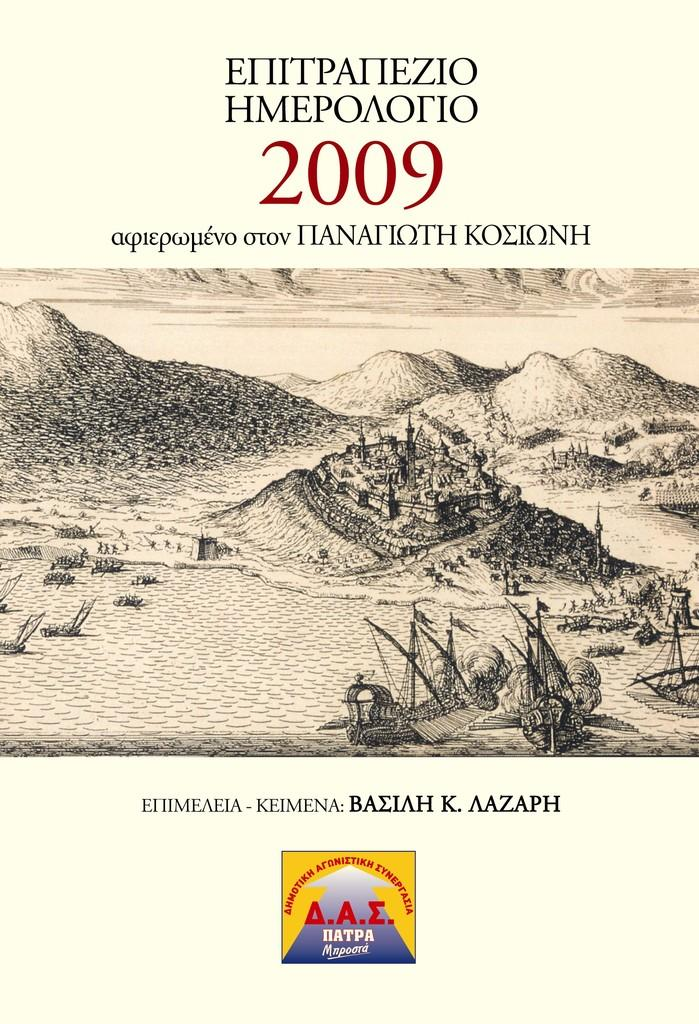<image>
Offer a succinct explanation of the picture presented. The foreign-language publication with a castle on the cover is dated 2009. 